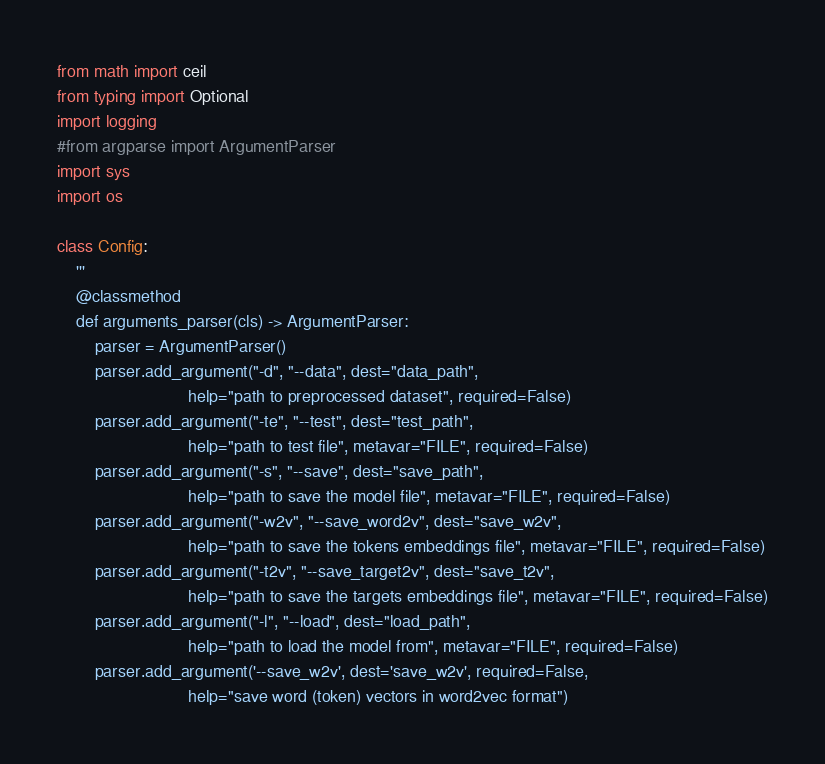<code> <loc_0><loc_0><loc_500><loc_500><_Python_>from math import ceil
from typing import Optional
import logging
#from argparse import ArgumentParser
import sys
import os

class Config:
    '''
    @classmethod
    def arguments_parser(cls) -> ArgumentParser:
        parser = ArgumentParser()
        parser.add_argument("-d", "--data", dest="data_path",
                            help="path to preprocessed dataset", required=False)
        parser.add_argument("-te", "--test", dest="test_path",
                            help="path to test file", metavar="FILE", required=False)
        parser.add_argument("-s", "--save", dest="save_path",
                            help="path to save the model file", metavar="FILE", required=False)
        parser.add_argument("-w2v", "--save_word2v", dest="save_w2v",
                            help="path to save the tokens embeddings file", metavar="FILE", required=False)
        parser.add_argument("-t2v", "--save_target2v", dest="save_t2v",
                            help="path to save the targets embeddings file", metavar="FILE", required=False)
        parser.add_argument("-l", "--load", dest="load_path",
                            help="path to load the model from", metavar="FILE", required=False)
        parser.add_argument('--save_w2v', dest='save_w2v', required=False,
                            help="save word (token) vectors in word2vec format")</code> 